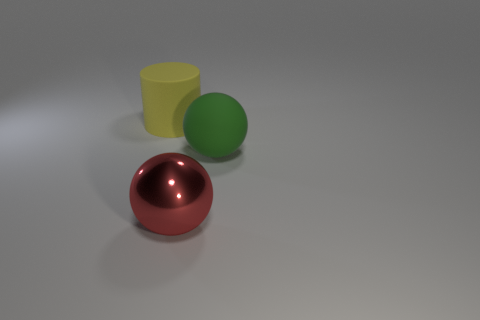Are there any tiny cyan things that have the same material as the red ball?
Your response must be concise. No. What shape is the big thing that is both behind the big red thing and on the left side of the green rubber object?
Give a very brief answer. Cylinder. What number of other objects are there of the same shape as the big green thing?
Make the answer very short. 1. What is the size of the metallic thing?
Ensure brevity in your answer.  Large. What number of things are either large red matte cylinders or big spheres?
Ensure brevity in your answer.  2. There is a matte object on the right side of the big red sphere; how big is it?
Make the answer very short. Large. What color is the large object that is both to the left of the green thing and in front of the cylinder?
Your answer should be compact. Red. Do the large sphere that is on the right side of the metal object and the red sphere have the same material?
Your response must be concise. No. There is a large shiny sphere; are there any big balls to the left of it?
Keep it short and to the point. No. Do the matte thing right of the yellow thing and the thing that is in front of the big green matte object have the same size?
Offer a very short reply. Yes. 